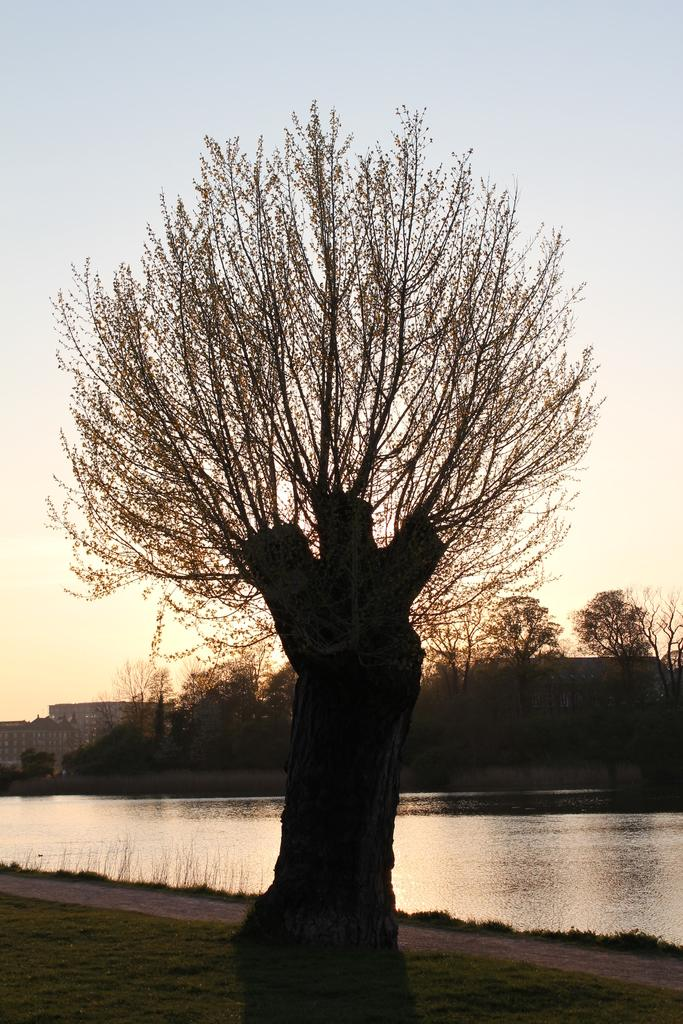What type of vegetation is present in the image? There is grass in the image. What other natural elements can be seen in the image? There is a tree in the image. What can be seen in the distance in the image? There is water, more trees, and buildings visible in the background of the image. What part of the natural environment is visible in the image? The sky is visible in the background of the image. What grade is the tree in the image? The tree in the image is not assigned a grade, as it is a natural object and not a student or subject in a school setting. How does the water in the background of the image drain away? The image does not provide information about how the water drains away, as it only shows a static scene. 